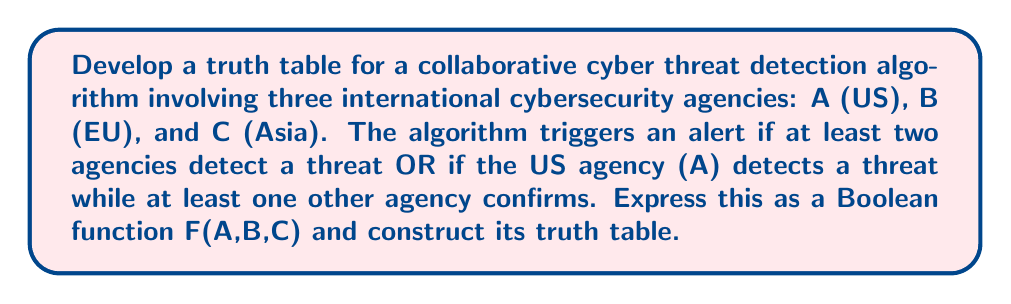Teach me how to tackle this problem. 1. First, let's express the Boolean function F(A,B,C) based on the given conditions:

   F(A,B,C) = (A ∧ B) ∨ (A ∧ C) ∨ (B ∧ C) ∨ (A ∧ (B ∨ C))

2. Simplify the function:
   F(A,B,C) = (A ∧ B) ∨ (A ∧ C) ∨ (B ∧ C)

   This simplification is possible because (A ∧ (B ∨ C)) is already covered by (A ∧ B) and (A ∧ C).

3. Construct the truth table:

   | A | B | C | (A ∧ B) | (A ∧ C) | (B ∧ C) | F(A,B,C) |
   |---|---|---|---------|---------|---------|----------|
   | 0 | 0 | 0 |    0    |    0    |    0    |    0     |
   | 0 | 0 | 1 |    0    |    0    |    0    |    0     |
   | 0 | 1 | 0 |    0    |    0    |    0    |    0     |
   | 0 | 1 | 1 |    0    |    0    |    1    |    1     |
   | 1 | 0 | 0 |    0    |    0    |    0    |    0     |
   | 1 | 0 | 1 |    0    |    1    |    0    |    1     |
   | 1 | 1 | 0 |    1    |    0    |    0    |    1     |
   | 1 | 1 | 1 |    1    |    1    |    1    |    1     |

4. The truth table shows that an alert is triggered (F(A,B,C) = 1) in four scenarios:
   - When all three agencies detect a threat (1,1,1)
   - When the US and EU agencies detect a threat (1,1,0)
   - When the US and Asian agencies detect a threat (1,0,1)
   - When the EU and Asian agencies detect a threat (0,1,1)

This collaborative approach ensures that the US doesn't have sole control over threat detection, addressing the skepticism about US leadership in cybersecurity.
Answer: F(A,B,C) = (A ∧ B) ∨ (A ∧ C) ∨ (B ∧ C) 